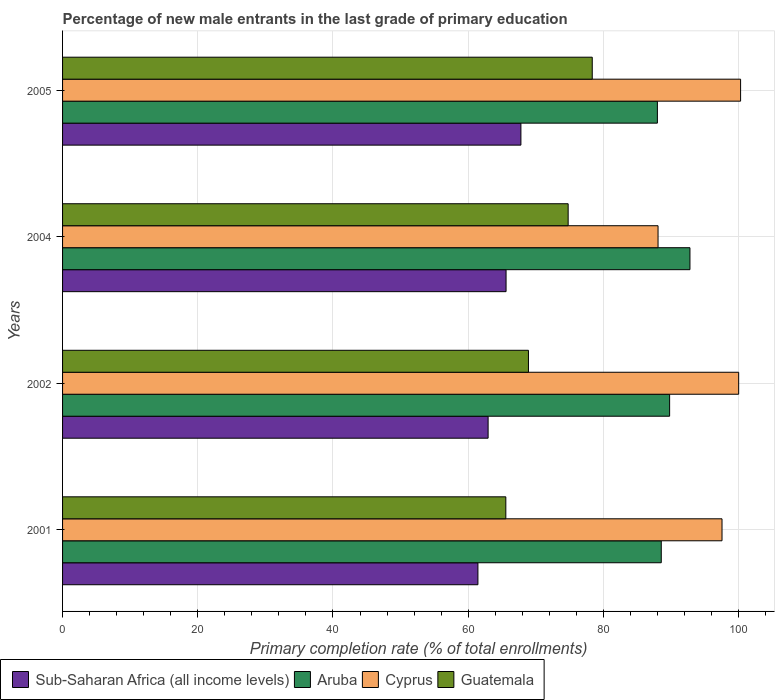How many groups of bars are there?
Your response must be concise. 4. Are the number of bars per tick equal to the number of legend labels?
Provide a short and direct response. Yes. Are the number of bars on each tick of the Y-axis equal?
Make the answer very short. Yes. How many bars are there on the 2nd tick from the top?
Give a very brief answer. 4. In how many cases, is the number of bars for a given year not equal to the number of legend labels?
Your answer should be very brief. 0. What is the percentage of new male entrants in Guatemala in 2001?
Make the answer very short. 65.57. Across all years, what is the maximum percentage of new male entrants in Cyprus?
Provide a succinct answer. 100.3. Across all years, what is the minimum percentage of new male entrants in Cyprus?
Your answer should be compact. 88.09. In which year was the percentage of new male entrants in Cyprus maximum?
Offer a very short reply. 2005. What is the total percentage of new male entrants in Guatemala in the graph?
Offer a very short reply. 287.64. What is the difference between the percentage of new male entrants in Aruba in 2001 and that in 2004?
Your answer should be very brief. -4.24. What is the difference between the percentage of new male entrants in Sub-Saharan Africa (all income levels) in 2004 and the percentage of new male entrants in Guatemala in 2001?
Ensure brevity in your answer.  0.03. What is the average percentage of new male entrants in Sub-Saharan Africa (all income levels) per year?
Ensure brevity in your answer.  64.45. In the year 2005, what is the difference between the percentage of new male entrants in Guatemala and percentage of new male entrants in Sub-Saharan Africa (all income levels)?
Provide a succinct answer. 10.56. What is the ratio of the percentage of new male entrants in Sub-Saharan Africa (all income levels) in 2001 to that in 2002?
Offer a terse response. 0.98. Is the percentage of new male entrants in Sub-Saharan Africa (all income levels) in 2002 less than that in 2005?
Provide a short and direct response. Yes. What is the difference between the highest and the second highest percentage of new male entrants in Aruba?
Your answer should be compact. 3.01. What is the difference between the highest and the lowest percentage of new male entrants in Guatemala?
Provide a short and direct response. 12.79. What does the 2nd bar from the top in 2004 represents?
Offer a terse response. Cyprus. What does the 4th bar from the bottom in 2004 represents?
Make the answer very short. Guatemala. What is the difference between two consecutive major ticks on the X-axis?
Make the answer very short. 20. Does the graph contain any zero values?
Provide a short and direct response. No. Does the graph contain grids?
Provide a succinct answer. Yes. What is the title of the graph?
Provide a short and direct response. Percentage of new male entrants in the last grade of primary education. What is the label or title of the X-axis?
Make the answer very short. Primary completion rate (% of total enrollments). What is the label or title of the Y-axis?
Keep it short and to the point. Years. What is the Primary completion rate (% of total enrollments) of Sub-Saharan Africa (all income levels) in 2001?
Make the answer very short. 61.44. What is the Primary completion rate (% of total enrollments) in Aruba in 2001?
Offer a terse response. 88.57. What is the Primary completion rate (% of total enrollments) in Cyprus in 2001?
Your answer should be compact. 97.55. What is the Primary completion rate (% of total enrollments) of Guatemala in 2001?
Your response must be concise. 65.57. What is the Primary completion rate (% of total enrollments) in Sub-Saharan Africa (all income levels) in 2002?
Offer a very short reply. 62.95. What is the Primary completion rate (% of total enrollments) of Aruba in 2002?
Your answer should be very brief. 89.8. What is the Primary completion rate (% of total enrollments) in Cyprus in 2002?
Ensure brevity in your answer.  100.02. What is the Primary completion rate (% of total enrollments) of Guatemala in 2002?
Give a very brief answer. 68.92. What is the Primary completion rate (% of total enrollments) of Sub-Saharan Africa (all income levels) in 2004?
Your answer should be very brief. 65.61. What is the Primary completion rate (% of total enrollments) of Aruba in 2004?
Your answer should be compact. 92.81. What is the Primary completion rate (% of total enrollments) in Cyprus in 2004?
Keep it short and to the point. 88.09. What is the Primary completion rate (% of total enrollments) of Guatemala in 2004?
Provide a short and direct response. 74.79. What is the Primary completion rate (% of total enrollments) in Sub-Saharan Africa (all income levels) in 2005?
Give a very brief answer. 67.8. What is the Primary completion rate (% of total enrollments) of Aruba in 2005?
Provide a short and direct response. 87.99. What is the Primary completion rate (% of total enrollments) in Cyprus in 2005?
Provide a succinct answer. 100.3. What is the Primary completion rate (% of total enrollments) in Guatemala in 2005?
Your answer should be very brief. 78.36. Across all years, what is the maximum Primary completion rate (% of total enrollments) in Sub-Saharan Africa (all income levels)?
Make the answer very short. 67.8. Across all years, what is the maximum Primary completion rate (% of total enrollments) in Aruba?
Offer a terse response. 92.81. Across all years, what is the maximum Primary completion rate (% of total enrollments) in Cyprus?
Make the answer very short. 100.3. Across all years, what is the maximum Primary completion rate (% of total enrollments) in Guatemala?
Provide a short and direct response. 78.36. Across all years, what is the minimum Primary completion rate (% of total enrollments) in Sub-Saharan Africa (all income levels)?
Keep it short and to the point. 61.44. Across all years, what is the minimum Primary completion rate (% of total enrollments) of Aruba?
Provide a short and direct response. 87.99. Across all years, what is the minimum Primary completion rate (% of total enrollments) of Cyprus?
Give a very brief answer. 88.09. Across all years, what is the minimum Primary completion rate (% of total enrollments) in Guatemala?
Provide a short and direct response. 65.57. What is the total Primary completion rate (% of total enrollments) in Sub-Saharan Africa (all income levels) in the graph?
Ensure brevity in your answer.  257.8. What is the total Primary completion rate (% of total enrollments) in Aruba in the graph?
Your response must be concise. 359.18. What is the total Primary completion rate (% of total enrollments) of Cyprus in the graph?
Ensure brevity in your answer.  385.97. What is the total Primary completion rate (% of total enrollments) of Guatemala in the graph?
Keep it short and to the point. 287.64. What is the difference between the Primary completion rate (% of total enrollments) of Sub-Saharan Africa (all income levels) in 2001 and that in 2002?
Provide a succinct answer. -1.51. What is the difference between the Primary completion rate (% of total enrollments) in Aruba in 2001 and that in 2002?
Offer a very short reply. -1.24. What is the difference between the Primary completion rate (% of total enrollments) of Cyprus in 2001 and that in 2002?
Keep it short and to the point. -2.46. What is the difference between the Primary completion rate (% of total enrollments) in Guatemala in 2001 and that in 2002?
Your answer should be compact. -3.35. What is the difference between the Primary completion rate (% of total enrollments) of Sub-Saharan Africa (all income levels) in 2001 and that in 2004?
Your response must be concise. -4.16. What is the difference between the Primary completion rate (% of total enrollments) of Aruba in 2001 and that in 2004?
Provide a short and direct response. -4.24. What is the difference between the Primary completion rate (% of total enrollments) in Cyprus in 2001 and that in 2004?
Keep it short and to the point. 9.46. What is the difference between the Primary completion rate (% of total enrollments) in Guatemala in 2001 and that in 2004?
Offer a very short reply. -9.22. What is the difference between the Primary completion rate (% of total enrollments) of Sub-Saharan Africa (all income levels) in 2001 and that in 2005?
Make the answer very short. -6.36. What is the difference between the Primary completion rate (% of total enrollments) in Aruba in 2001 and that in 2005?
Your answer should be very brief. 0.57. What is the difference between the Primary completion rate (% of total enrollments) in Cyprus in 2001 and that in 2005?
Your answer should be compact. -2.75. What is the difference between the Primary completion rate (% of total enrollments) in Guatemala in 2001 and that in 2005?
Give a very brief answer. -12.79. What is the difference between the Primary completion rate (% of total enrollments) in Sub-Saharan Africa (all income levels) in 2002 and that in 2004?
Your response must be concise. -2.65. What is the difference between the Primary completion rate (% of total enrollments) of Aruba in 2002 and that in 2004?
Ensure brevity in your answer.  -3.01. What is the difference between the Primary completion rate (% of total enrollments) in Cyprus in 2002 and that in 2004?
Your answer should be very brief. 11.93. What is the difference between the Primary completion rate (% of total enrollments) in Guatemala in 2002 and that in 2004?
Provide a short and direct response. -5.87. What is the difference between the Primary completion rate (% of total enrollments) of Sub-Saharan Africa (all income levels) in 2002 and that in 2005?
Offer a terse response. -4.85. What is the difference between the Primary completion rate (% of total enrollments) in Aruba in 2002 and that in 2005?
Offer a very short reply. 1.81. What is the difference between the Primary completion rate (% of total enrollments) of Cyprus in 2002 and that in 2005?
Your response must be concise. -0.28. What is the difference between the Primary completion rate (% of total enrollments) in Guatemala in 2002 and that in 2005?
Your response must be concise. -9.44. What is the difference between the Primary completion rate (% of total enrollments) in Sub-Saharan Africa (all income levels) in 2004 and that in 2005?
Your answer should be very brief. -2.2. What is the difference between the Primary completion rate (% of total enrollments) of Aruba in 2004 and that in 2005?
Offer a very short reply. 4.82. What is the difference between the Primary completion rate (% of total enrollments) in Cyprus in 2004 and that in 2005?
Provide a succinct answer. -12.21. What is the difference between the Primary completion rate (% of total enrollments) in Guatemala in 2004 and that in 2005?
Give a very brief answer. -3.57. What is the difference between the Primary completion rate (% of total enrollments) in Sub-Saharan Africa (all income levels) in 2001 and the Primary completion rate (% of total enrollments) in Aruba in 2002?
Offer a terse response. -28.36. What is the difference between the Primary completion rate (% of total enrollments) in Sub-Saharan Africa (all income levels) in 2001 and the Primary completion rate (% of total enrollments) in Cyprus in 2002?
Provide a short and direct response. -38.57. What is the difference between the Primary completion rate (% of total enrollments) of Sub-Saharan Africa (all income levels) in 2001 and the Primary completion rate (% of total enrollments) of Guatemala in 2002?
Offer a very short reply. -7.48. What is the difference between the Primary completion rate (% of total enrollments) in Aruba in 2001 and the Primary completion rate (% of total enrollments) in Cyprus in 2002?
Offer a very short reply. -11.45. What is the difference between the Primary completion rate (% of total enrollments) in Aruba in 2001 and the Primary completion rate (% of total enrollments) in Guatemala in 2002?
Your answer should be compact. 19.65. What is the difference between the Primary completion rate (% of total enrollments) in Cyprus in 2001 and the Primary completion rate (% of total enrollments) in Guatemala in 2002?
Your answer should be compact. 28.64. What is the difference between the Primary completion rate (% of total enrollments) in Sub-Saharan Africa (all income levels) in 2001 and the Primary completion rate (% of total enrollments) in Aruba in 2004?
Provide a short and direct response. -31.37. What is the difference between the Primary completion rate (% of total enrollments) in Sub-Saharan Africa (all income levels) in 2001 and the Primary completion rate (% of total enrollments) in Cyprus in 2004?
Provide a succinct answer. -26.65. What is the difference between the Primary completion rate (% of total enrollments) of Sub-Saharan Africa (all income levels) in 2001 and the Primary completion rate (% of total enrollments) of Guatemala in 2004?
Provide a short and direct response. -13.35. What is the difference between the Primary completion rate (% of total enrollments) in Aruba in 2001 and the Primary completion rate (% of total enrollments) in Cyprus in 2004?
Ensure brevity in your answer.  0.48. What is the difference between the Primary completion rate (% of total enrollments) in Aruba in 2001 and the Primary completion rate (% of total enrollments) in Guatemala in 2004?
Ensure brevity in your answer.  13.77. What is the difference between the Primary completion rate (% of total enrollments) of Cyprus in 2001 and the Primary completion rate (% of total enrollments) of Guatemala in 2004?
Your response must be concise. 22.76. What is the difference between the Primary completion rate (% of total enrollments) in Sub-Saharan Africa (all income levels) in 2001 and the Primary completion rate (% of total enrollments) in Aruba in 2005?
Make the answer very short. -26.55. What is the difference between the Primary completion rate (% of total enrollments) of Sub-Saharan Africa (all income levels) in 2001 and the Primary completion rate (% of total enrollments) of Cyprus in 2005?
Offer a terse response. -38.86. What is the difference between the Primary completion rate (% of total enrollments) of Sub-Saharan Africa (all income levels) in 2001 and the Primary completion rate (% of total enrollments) of Guatemala in 2005?
Your response must be concise. -16.91. What is the difference between the Primary completion rate (% of total enrollments) in Aruba in 2001 and the Primary completion rate (% of total enrollments) in Cyprus in 2005?
Your answer should be compact. -11.73. What is the difference between the Primary completion rate (% of total enrollments) in Aruba in 2001 and the Primary completion rate (% of total enrollments) in Guatemala in 2005?
Offer a terse response. 10.21. What is the difference between the Primary completion rate (% of total enrollments) of Cyprus in 2001 and the Primary completion rate (% of total enrollments) of Guatemala in 2005?
Offer a terse response. 19.2. What is the difference between the Primary completion rate (% of total enrollments) of Sub-Saharan Africa (all income levels) in 2002 and the Primary completion rate (% of total enrollments) of Aruba in 2004?
Provide a succinct answer. -29.86. What is the difference between the Primary completion rate (% of total enrollments) of Sub-Saharan Africa (all income levels) in 2002 and the Primary completion rate (% of total enrollments) of Cyprus in 2004?
Your response must be concise. -25.14. What is the difference between the Primary completion rate (% of total enrollments) in Sub-Saharan Africa (all income levels) in 2002 and the Primary completion rate (% of total enrollments) in Guatemala in 2004?
Your response must be concise. -11.84. What is the difference between the Primary completion rate (% of total enrollments) in Aruba in 2002 and the Primary completion rate (% of total enrollments) in Cyprus in 2004?
Provide a succinct answer. 1.71. What is the difference between the Primary completion rate (% of total enrollments) of Aruba in 2002 and the Primary completion rate (% of total enrollments) of Guatemala in 2004?
Give a very brief answer. 15.01. What is the difference between the Primary completion rate (% of total enrollments) in Cyprus in 2002 and the Primary completion rate (% of total enrollments) in Guatemala in 2004?
Your response must be concise. 25.23. What is the difference between the Primary completion rate (% of total enrollments) of Sub-Saharan Africa (all income levels) in 2002 and the Primary completion rate (% of total enrollments) of Aruba in 2005?
Offer a very short reply. -25.04. What is the difference between the Primary completion rate (% of total enrollments) in Sub-Saharan Africa (all income levels) in 2002 and the Primary completion rate (% of total enrollments) in Cyprus in 2005?
Ensure brevity in your answer.  -37.35. What is the difference between the Primary completion rate (% of total enrollments) in Sub-Saharan Africa (all income levels) in 2002 and the Primary completion rate (% of total enrollments) in Guatemala in 2005?
Ensure brevity in your answer.  -15.41. What is the difference between the Primary completion rate (% of total enrollments) in Aruba in 2002 and the Primary completion rate (% of total enrollments) in Cyprus in 2005?
Keep it short and to the point. -10.5. What is the difference between the Primary completion rate (% of total enrollments) in Aruba in 2002 and the Primary completion rate (% of total enrollments) in Guatemala in 2005?
Ensure brevity in your answer.  11.45. What is the difference between the Primary completion rate (% of total enrollments) of Cyprus in 2002 and the Primary completion rate (% of total enrollments) of Guatemala in 2005?
Provide a succinct answer. 21.66. What is the difference between the Primary completion rate (% of total enrollments) of Sub-Saharan Africa (all income levels) in 2004 and the Primary completion rate (% of total enrollments) of Aruba in 2005?
Your response must be concise. -22.39. What is the difference between the Primary completion rate (% of total enrollments) in Sub-Saharan Africa (all income levels) in 2004 and the Primary completion rate (% of total enrollments) in Cyprus in 2005?
Offer a terse response. -34.7. What is the difference between the Primary completion rate (% of total enrollments) in Sub-Saharan Africa (all income levels) in 2004 and the Primary completion rate (% of total enrollments) in Guatemala in 2005?
Offer a terse response. -12.75. What is the difference between the Primary completion rate (% of total enrollments) in Aruba in 2004 and the Primary completion rate (% of total enrollments) in Cyprus in 2005?
Offer a very short reply. -7.49. What is the difference between the Primary completion rate (% of total enrollments) of Aruba in 2004 and the Primary completion rate (% of total enrollments) of Guatemala in 2005?
Provide a succinct answer. 14.45. What is the difference between the Primary completion rate (% of total enrollments) in Cyprus in 2004 and the Primary completion rate (% of total enrollments) in Guatemala in 2005?
Keep it short and to the point. 9.73. What is the average Primary completion rate (% of total enrollments) of Sub-Saharan Africa (all income levels) per year?
Give a very brief answer. 64.45. What is the average Primary completion rate (% of total enrollments) in Aruba per year?
Offer a very short reply. 89.79. What is the average Primary completion rate (% of total enrollments) in Cyprus per year?
Give a very brief answer. 96.49. What is the average Primary completion rate (% of total enrollments) of Guatemala per year?
Offer a very short reply. 71.91. In the year 2001, what is the difference between the Primary completion rate (% of total enrollments) of Sub-Saharan Africa (all income levels) and Primary completion rate (% of total enrollments) of Aruba?
Your answer should be compact. -27.12. In the year 2001, what is the difference between the Primary completion rate (% of total enrollments) in Sub-Saharan Africa (all income levels) and Primary completion rate (% of total enrollments) in Cyprus?
Your answer should be compact. -36.11. In the year 2001, what is the difference between the Primary completion rate (% of total enrollments) in Sub-Saharan Africa (all income levels) and Primary completion rate (% of total enrollments) in Guatemala?
Ensure brevity in your answer.  -4.13. In the year 2001, what is the difference between the Primary completion rate (% of total enrollments) in Aruba and Primary completion rate (% of total enrollments) in Cyprus?
Ensure brevity in your answer.  -8.99. In the year 2001, what is the difference between the Primary completion rate (% of total enrollments) in Aruba and Primary completion rate (% of total enrollments) in Guatemala?
Ensure brevity in your answer.  22.99. In the year 2001, what is the difference between the Primary completion rate (% of total enrollments) in Cyprus and Primary completion rate (% of total enrollments) in Guatemala?
Your answer should be very brief. 31.98. In the year 2002, what is the difference between the Primary completion rate (% of total enrollments) of Sub-Saharan Africa (all income levels) and Primary completion rate (% of total enrollments) of Aruba?
Offer a terse response. -26.85. In the year 2002, what is the difference between the Primary completion rate (% of total enrollments) of Sub-Saharan Africa (all income levels) and Primary completion rate (% of total enrollments) of Cyprus?
Your answer should be compact. -37.07. In the year 2002, what is the difference between the Primary completion rate (% of total enrollments) in Sub-Saharan Africa (all income levels) and Primary completion rate (% of total enrollments) in Guatemala?
Ensure brevity in your answer.  -5.97. In the year 2002, what is the difference between the Primary completion rate (% of total enrollments) in Aruba and Primary completion rate (% of total enrollments) in Cyprus?
Provide a succinct answer. -10.21. In the year 2002, what is the difference between the Primary completion rate (% of total enrollments) of Aruba and Primary completion rate (% of total enrollments) of Guatemala?
Keep it short and to the point. 20.88. In the year 2002, what is the difference between the Primary completion rate (% of total enrollments) of Cyprus and Primary completion rate (% of total enrollments) of Guatemala?
Your answer should be very brief. 31.1. In the year 2004, what is the difference between the Primary completion rate (% of total enrollments) in Sub-Saharan Africa (all income levels) and Primary completion rate (% of total enrollments) in Aruba?
Offer a terse response. -27.2. In the year 2004, what is the difference between the Primary completion rate (% of total enrollments) in Sub-Saharan Africa (all income levels) and Primary completion rate (% of total enrollments) in Cyprus?
Give a very brief answer. -22.48. In the year 2004, what is the difference between the Primary completion rate (% of total enrollments) of Sub-Saharan Africa (all income levels) and Primary completion rate (% of total enrollments) of Guatemala?
Ensure brevity in your answer.  -9.19. In the year 2004, what is the difference between the Primary completion rate (% of total enrollments) in Aruba and Primary completion rate (% of total enrollments) in Cyprus?
Your response must be concise. 4.72. In the year 2004, what is the difference between the Primary completion rate (% of total enrollments) in Aruba and Primary completion rate (% of total enrollments) in Guatemala?
Provide a succinct answer. 18.02. In the year 2004, what is the difference between the Primary completion rate (% of total enrollments) of Cyprus and Primary completion rate (% of total enrollments) of Guatemala?
Keep it short and to the point. 13.3. In the year 2005, what is the difference between the Primary completion rate (% of total enrollments) in Sub-Saharan Africa (all income levels) and Primary completion rate (% of total enrollments) in Aruba?
Ensure brevity in your answer.  -20.19. In the year 2005, what is the difference between the Primary completion rate (% of total enrollments) in Sub-Saharan Africa (all income levels) and Primary completion rate (% of total enrollments) in Cyprus?
Provide a short and direct response. -32.5. In the year 2005, what is the difference between the Primary completion rate (% of total enrollments) in Sub-Saharan Africa (all income levels) and Primary completion rate (% of total enrollments) in Guatemala?
Offer a very short reply. -10.56. In the year 2005, what is the difference between the Primary completion rate (% of total enrollments) of Aruba and Primary completion rate (% of total enrollments) of Cyprus?
Keep it short and to the point. -12.31. In the year 2005, what is the difference between the Primary completion rate (% of total enrollments) in Aruba and Primary completion rate (% of total enrollments) in Guatemala?
Keep it short and to the point. 9.64. In the year 2005, what is the difference between the Primary completion rate (% of total enrollments) in Cyprus and Primary completion rate (% of total enrollments) in Guatemala?
Offer a very short reply. 21.94. What is the ratio of the Primary completion rate (% of total enrollments) in Sub-Saharan Africa (all income levels) in 2001 to that in 2002?
Provide a short and direct response. 0.98. What is the ratio of the Primary completion rate (% of total enrollments) in Aruba in 2001 to that in 2002?
Make the answer very short. 0.99. What is the ratio of the Primary completion rate (% of total enrollments) in Cyprus in 2001 to that in 2002?
Make the answer very short. 0.98. What is the ratio of the Primary completion rate (% of total enrollments) in Guatemala in 2001 to that in 2002?
Keep it short and to the point. 0.95. What is the ratio of the Primary completion rate (% of total enrollments) of Sub-Saharan Africa (all income levels) in 2001 to that in 2004?
Offer a terse response. 0.94. What is the ratio of the Primary completion rate (% of total enrollments) of Aruba in 2001 to that in 2004?
Make the answer very short. 0.95. What is the ratio of the Primary completion rate (% of total enrollments) of Cyprus in 2001 to that in 2004?
Give a very brief answer. 1.11. What is the ratio of the Primary completion rate (% of total enrollments) of Guatemala in 2001 to that in 2004?
Offer a terse response. 0.88. What is the ratio of the Primary completion rate (% of total enrollments) in Sub-Saharan Africa (all income levels) in 2001 to that in 2005?
Provide a succinct answer. 0.91. What is the ratio of the Primary completion rate (% of total enrollments) of Aruba in 2001 to that in 2005?
Provide a short and direct response. 1.01. What is the ratio of the Primary completion rate (% of total enrollments) in Cyprus in 2001 to that in 2005?
Make the answer very short. 0.97. What is the ratio of the Primary completion rate (% of total enrollments) in Guatemala in 2001 to that in 2005?
Make the answer very short. 0.84. What is the ratio of the Primary completion rate (% of total enrollments) of Sub-Saharan Africa (all income levels) in 2002 to that in 2004?
Your answer should be compact. 0.96. What is the ratio of the Primary completion rate (% of total enrollments) of Aruba in 2002 to that in 2004?
Give a very brief answer. 0.97. What is the ratio of the Primary completion rate (% of total enrollments) of Cyprus in 2002 to that in 2004?
Ensure brevity in your answer.  1.14. What is the ratio of the Primary completion rate (% of total enrollments) of Guatemala in 2002 to that in 2004?
Ensure brevity in your answer.  0.92. What is the ratio of the Primary completion rate (% of total enrollments) of Sub-Saharan Africa (all income levels) in 2002 to that in 2005?
Keep it short and to the point. 0.93. What is the ratio of the Primary completion rate (% of total enrollments) of Aruba in 2002 to that in 2005?
Offer a very short reply. 1.02. What is the ratio of the Primary completion rate (% of total enrollments) of Guatemala in 2002 to that in 2005?
Make the answer very short. 0.88. What is the ratio of the Primary completion rate (% of total enrollments) of Sub-Saharan Africa (all income levels) in 2004 to that in 2005?
Provide a short and direct response. 0.97. What is the ratio of the Primary completion rate (% of total enrollments) of Aruba in 2004 to that in 2005?
Your answer should be very brief. 1.05. What is the ratio of the Primary completion rate (% of total enrollments) of Cyprus in 2004 to that in 2005?
Give a very brief answer. 0.88. What is the ratio of the Primary completion rate (% of total enrollments) of Guatemala in 2004 to that in 2005?
Your response must be concise. 0.95. What is the difference between the highest and the second highest Primary completion rate (% of total enrollments) in Sub-Saharan Africa (all income levels)?
Provide a short and direct response. 2.2. What is the difference between the highest and the second highest Primary completion rate (% of total enrollments) in Aruba?
Your response must be concise. 3.01. What is the difference between the highest and the second highest Primary completion rate (% of total enrollments) of Cyprus?
Ensure brevity in your answer.  0.28. What is the difference between the highest and the second highest Primary completion rate (% of total enrollments) of Guatemala?
Ensure brevity in your answer.  3.57. What is the difference between the highest and the lowest Primary completion rate (% of total enrollments) of Sub-Saharan Africa (all income levels)?
Your answer should be compact. 6.36. What is the difference between the highest and the lowest Primary completion rate (% of total enrollments) in Aruba?
Make the answer very short. 4.82. What is the difference between the highest and the lowest Primary completion rate (% of total enrollments) of Cyprus?
Keep it short and to the point. 12.21. What is the difference between the highest and the lowest Primary completion rate (% of total enrollments) in Guatemala?
Your answer should be compact. 12.79. 